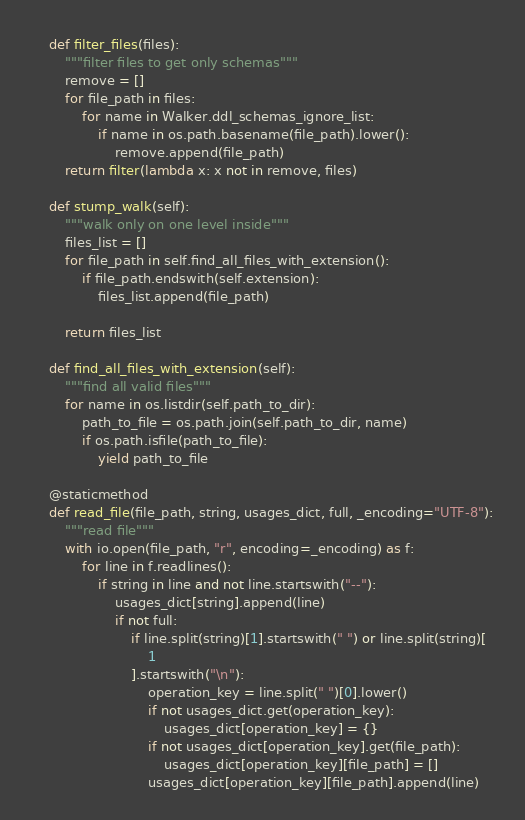<code> <loc_0><loc_0><loc_500><loc_500><_Python_>    def filter_files(files):
        """filter files to get only schemas"""
        remove = []
        for file_path in files:
            for name in Walker.ddl_schemas_ignore_list:
                if name in os.path.basename(file_path).lower():
                    remove.append(file_path)
        return filter(lambda x: x not in remove, files)

    def stump_walk(self):
        """walk only on one level inside"""
        files_list = []
        for file_path in self.find_all_files_with_extension():
            if file_path.endswith(self.extension):
                files_list.append(file_path)

        return files_list

    def find_all_files_with_extension(self):
        """find all valid files"""
        for name in os.listdir(self.path_to_dir):
            path_to_file = os.path.join(self.path_to_dir, name)
            if os.path.isfile(path_to_file):
                yield path_to_file

    @staticmethod
    def read_file(file_path, string, usages_dict, full, _encoding="UTF-8"):
        """read file"""
        with io.open(file_path, "r", encoding=_encoding) as f:
            for line in f.readlines():
                if string in line and not line.startswith("--"):
                    usages_dict[string].append(line)
                    if not full:
                        if line.split(string)[1].startswith(" ") or line.split(string)[
                            1
                        ].startswith("\n"):
                            operation_key = line.split(" ")[0].lower()
                            if not usages_dict.get(operation_key):
                                usages_dict[operation_key] = {}
                            if not usages_dict[operation_key].get(file_path):
                                usages_dict[operation_key][file_path] = []
                            usages_dict[operation_key][file_path].append(line)
</code> 